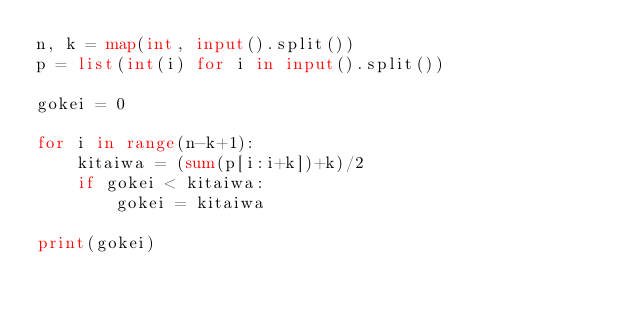Convert code to text. <code><loc_0><loc_0><loc_500><loc_500><_Python_>n, k = map(int, input().split())
p = list(int(i) for i in input().split())

gokei = 0

for i in range(n-k+1):
    kitaiwa = (sum(p[i:i+k])+k)/2
    if gokei < kitaiwa:
        gokei = kitaiwa

print(gokei)</code> 